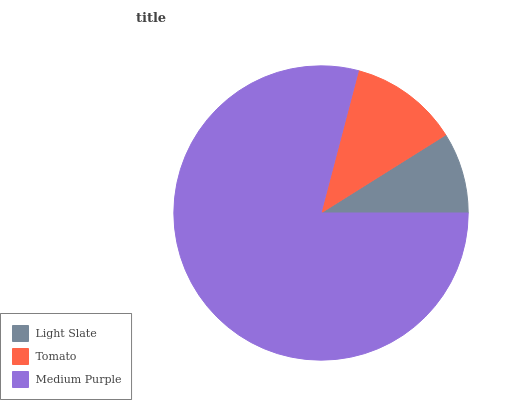Is Light Slate the minimum?
Answer yes or no. Yes. Is Medium Purple the maximum?
Answer yes or no. Yes. Is Tomato the minimum?
Answer yes or no. No. Is Tomato the maximum?
Answer yes or no. No. Is Tomato greater than Light Slate?
Answer yes or no. Yes. Is Light Slate less than Tomato?
Answer yes or no. Yes. Is Light Slate greater than Tomato?
Answer yes or no. No. Is Tomato less than Light Slate?
Answer yes or no. No. Is Tomato the high median?
Answer yes or no. Yes. Is Tomato the low median?
Answer yes or no. Yes. Is Medium Purple the high median?
Answer yes or no. No. Is Medium Purple the low median?
Answer yes or no. No. 